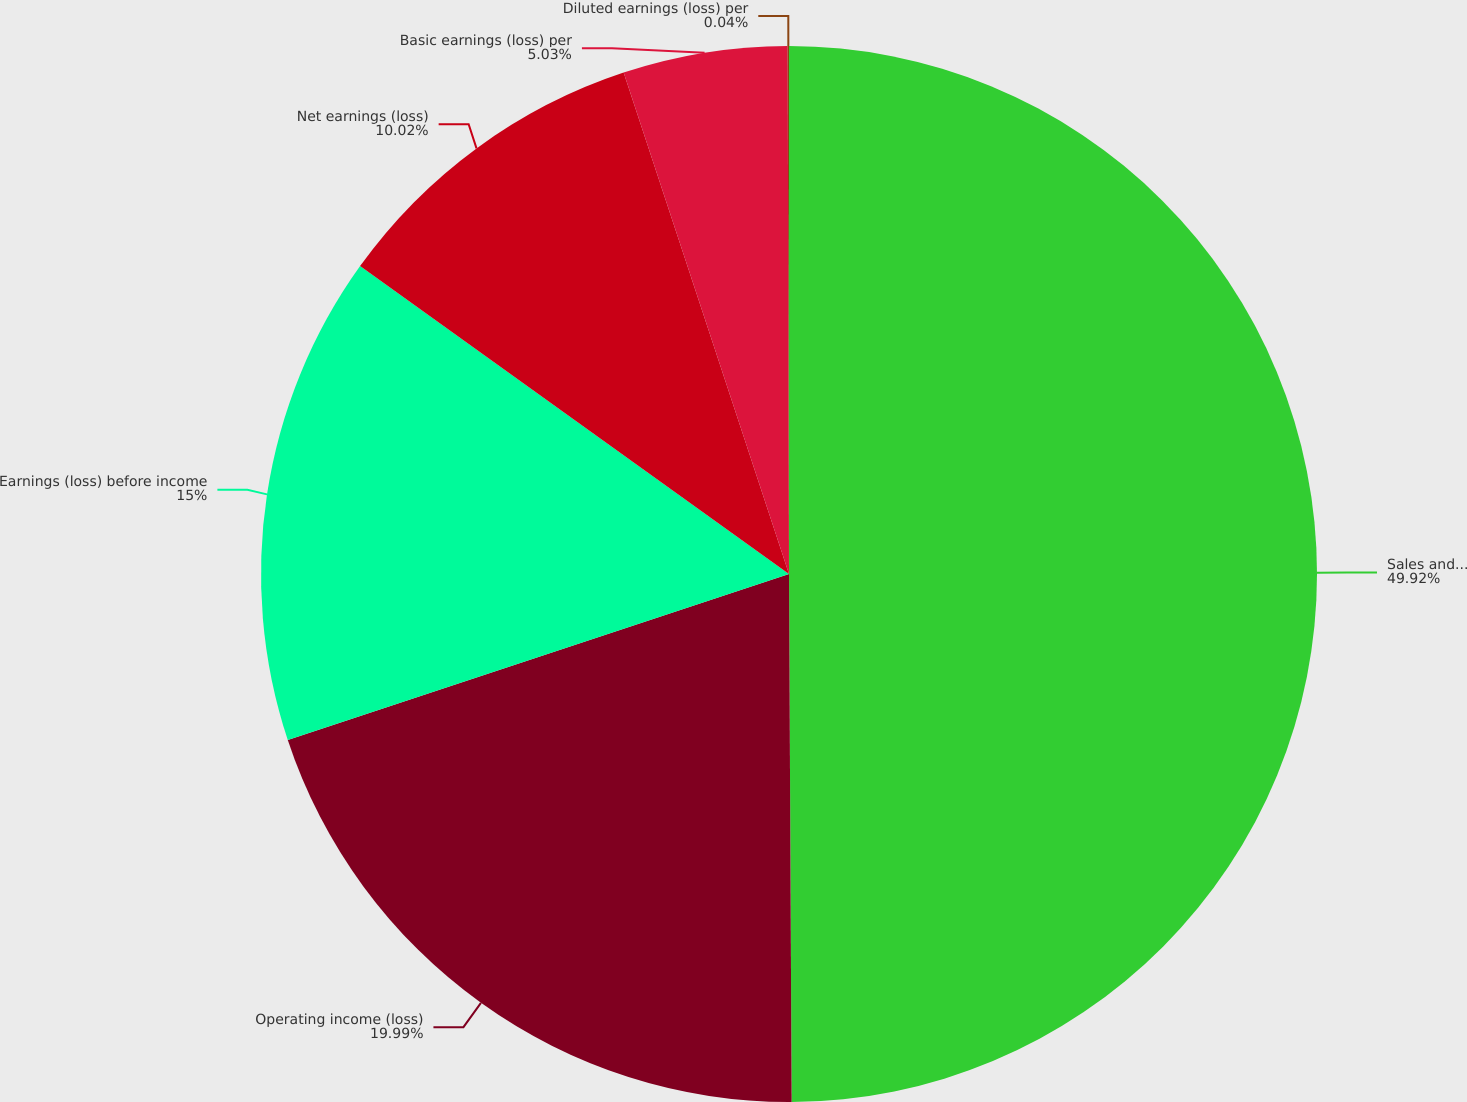Convert chart. <chart><loc_0><loc_0><loc_500><loc_500><pie_chart><fcel>Sales and service revenues<fcel>Operating income (loss)<fcel>Earnings (loss) before income<fcel>Net earnings (loss)<fcel>Basic earnings (loss) per<fcel>Diluted earnings (loss) per<nl><fcel>49.92%<fcel>19.99%<fcel>15.0%<fcel>10.02%<fcel>5.03%<fcel>0.04%<nl></chart> 